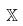Convert formula to latex. <formula><loc_0><loc_0><loc_500><loc_500>\mathbb { X }</formula> 